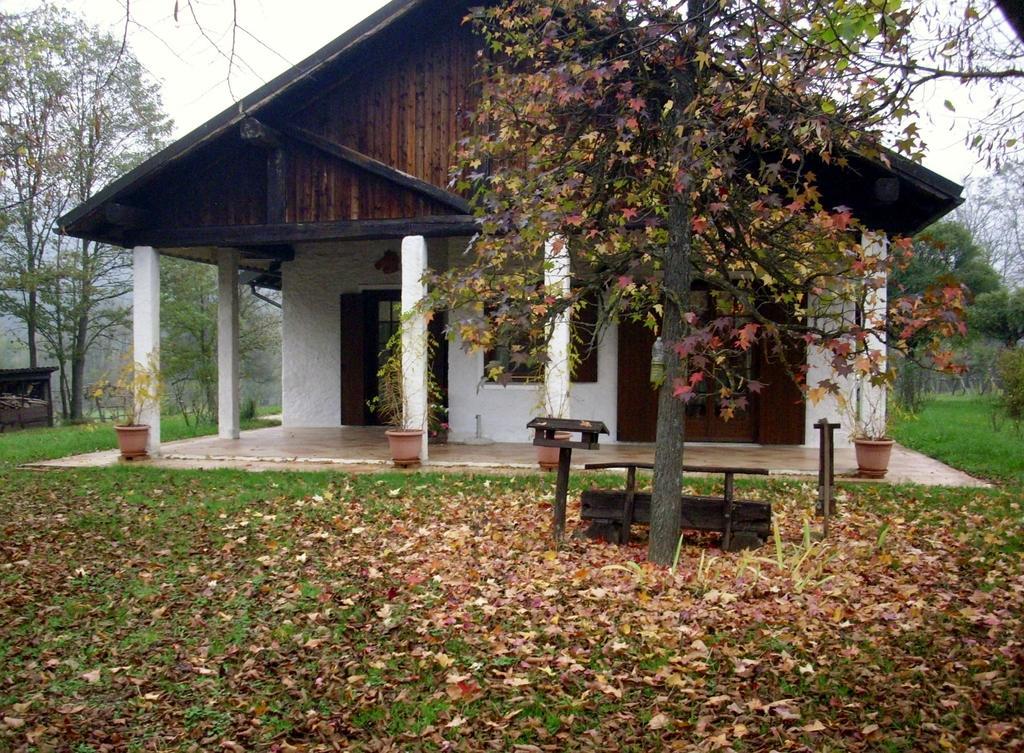Describe this image in one or two sentences. In this image in the center there is one house and also there are some trees, flower pots and plants. At the bottom there is grass and some dry leaves, in the background there are some trees. At the top there is sky. 